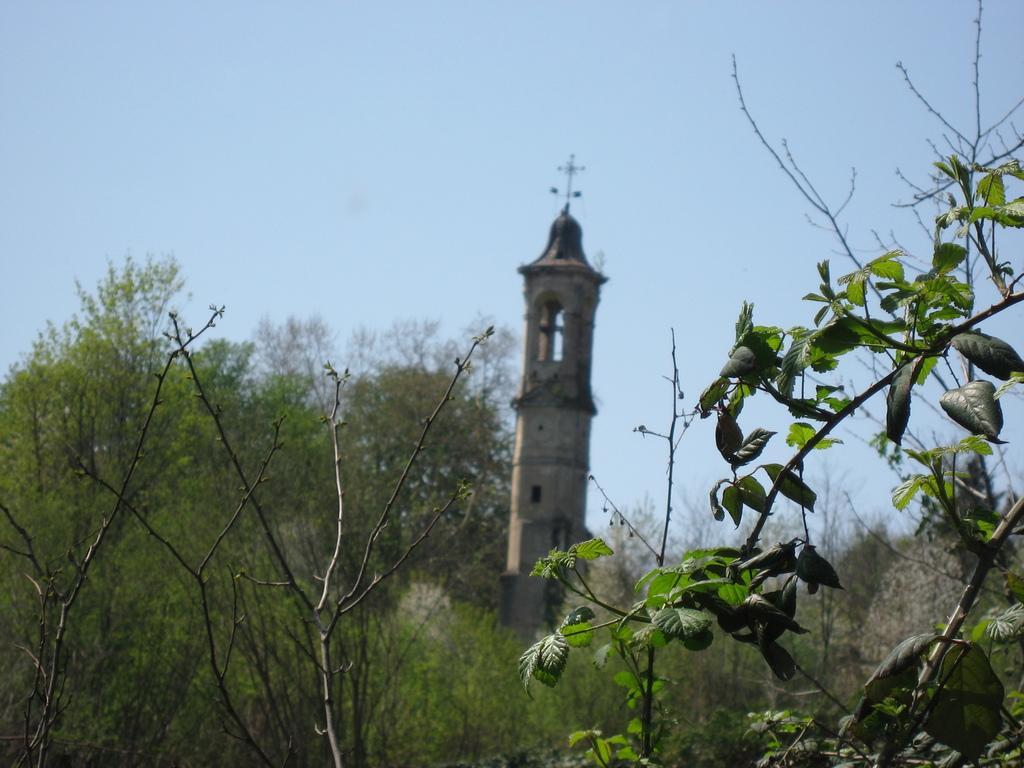Please provide a concise description of this image. In this picture there is greenery at the bottom side of the image and there is a tower in the center of the image. 